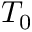<formula> <loc_0><loc_0><loc_500><loc_500>T _ { 0 }</formula> 